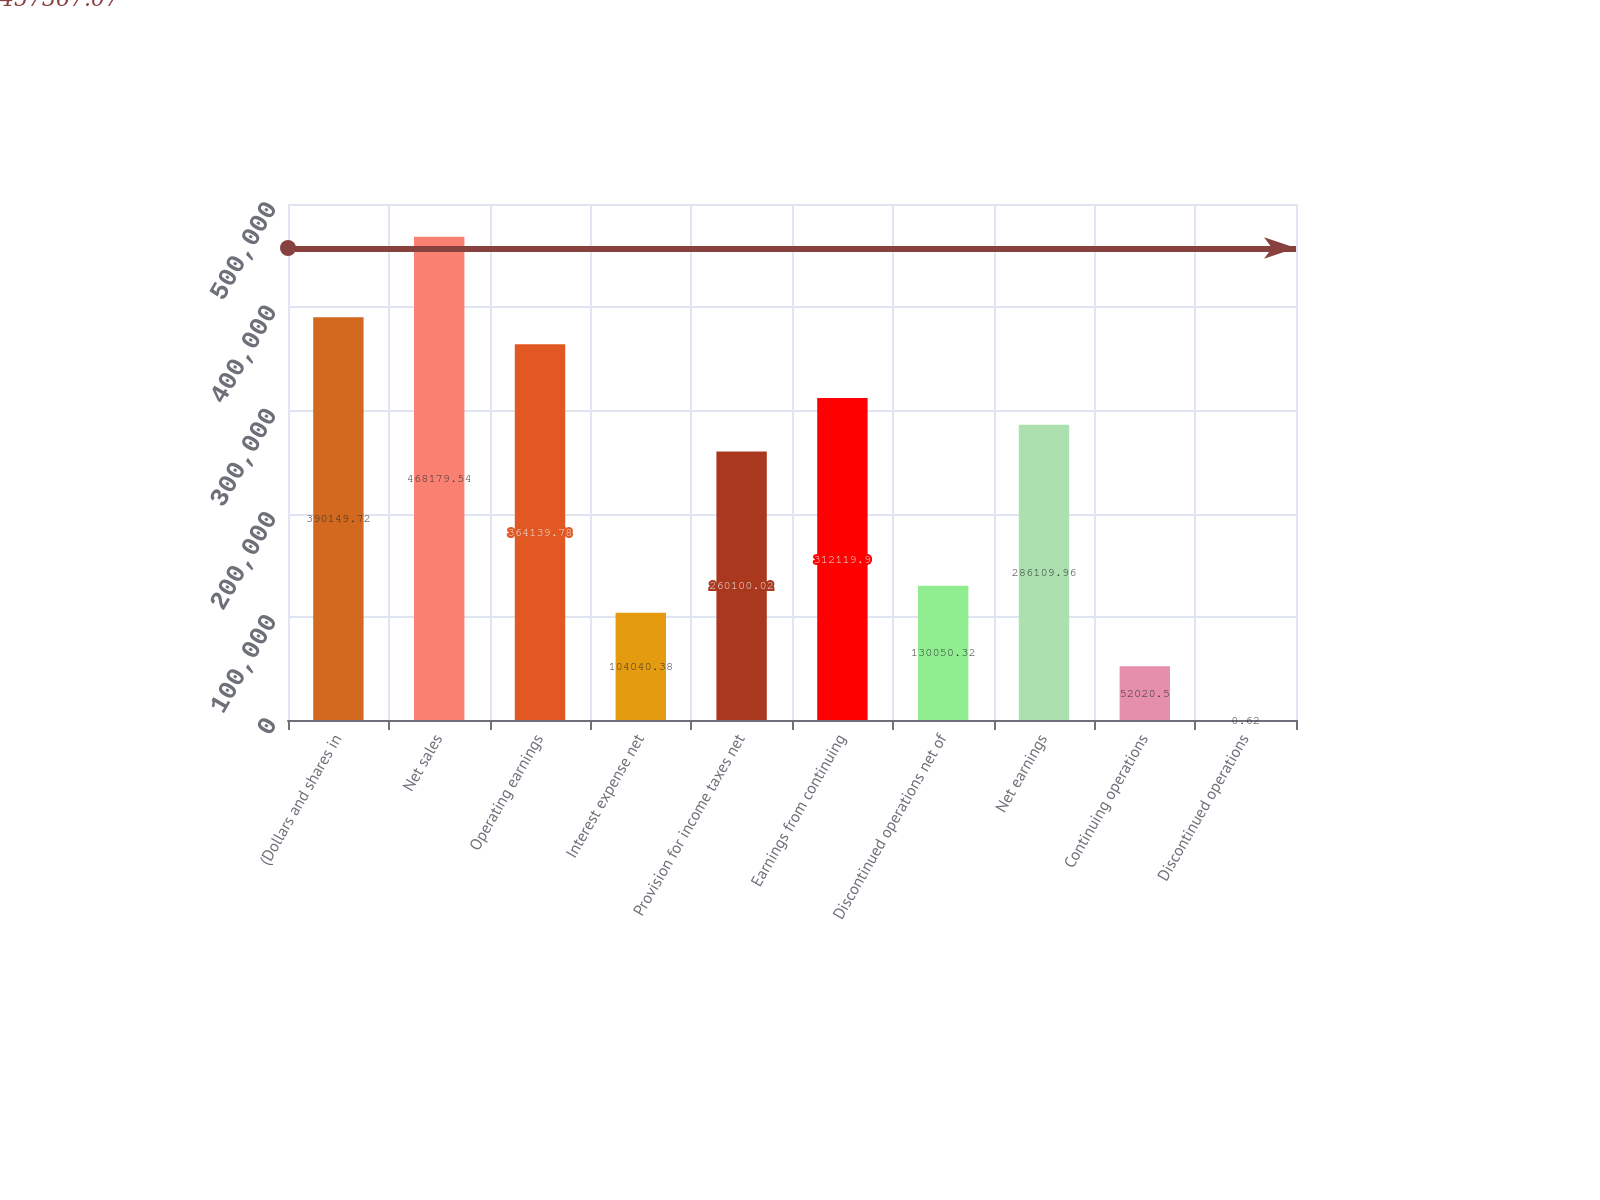<chart> <loc_0><loc_0><loc_500><loc_500><bar_chart><fcel>(Dollars and shares in<fcel>Net sales<fcel>Operating earnings<fcel>Interest expense net<fcel>Provision for income taxes net<fcel>Earnings from continuing<fcel>Discontinued operations net of<fcel>Net earnings<fcel>Continuing operations<fcel>Discontinued operations<nl><fcel>390150<fcel>468180<fcel>364140<fcel>104040<fcel>260100<fcel>312120<fcel>130050<fcel>286110<fcel>52020.5<fcel>0.62<nl></chart> 